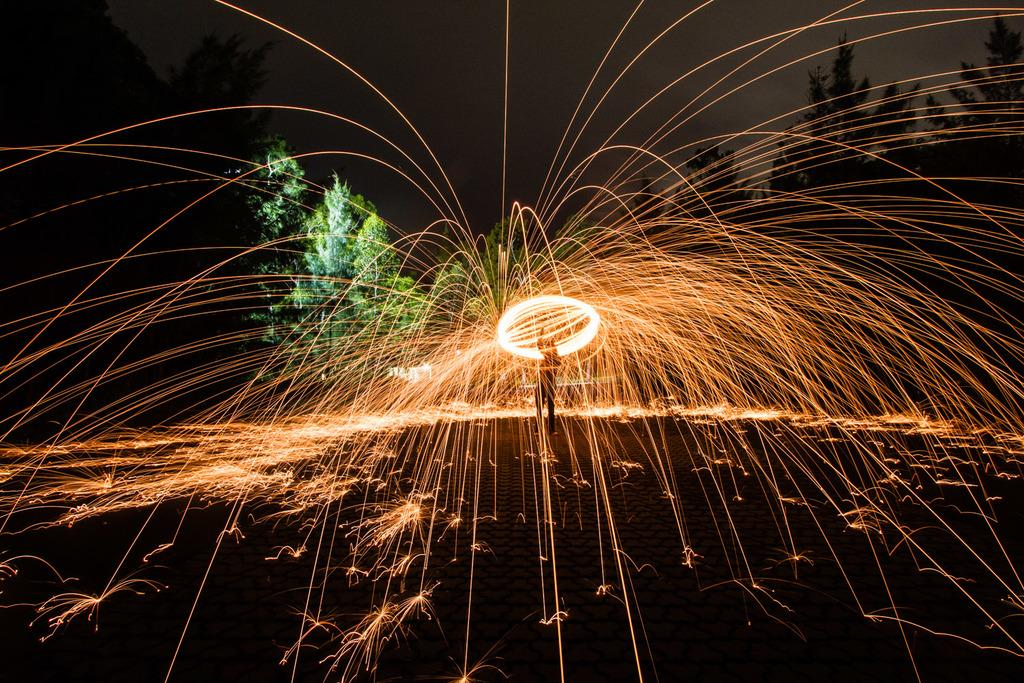What is happening in the image? There is a person in the image who is playing with fire. Can you describe the setting of the image? The background of the image is the sky. What type of protest is happening in the image? There is no protest present in the image; it features a person playing with fire against a sky background. What kind of activity is the person on the bike doing in the image? There is no bike or bike-related activity in the image; it only shows a person playing with fire. 